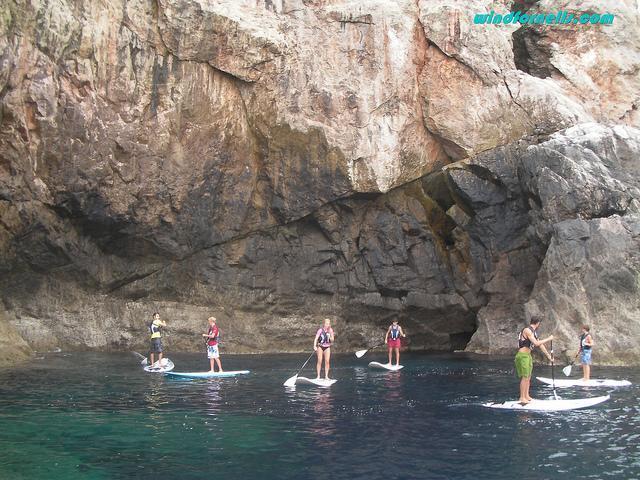How many people?
Give a very brief answer. 6. How many hot dogs are on the buns?
Give a very brief answer. 0. 